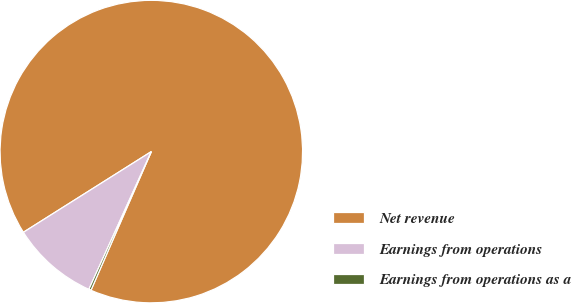<chart> <loc_0><loc_0><loc_500><loc_500><pie_chart><fcel>Net revenue<fcel>Earnings from operations<fcel>Earnings from operations as a<nl><fcel>90.49%<fcel>9.27%<fcel>0.24%<nl></chart> 